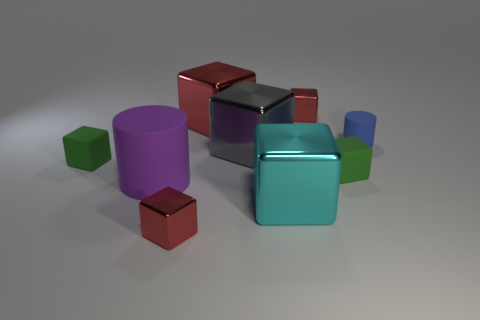Subtract all yellow spheres. How many red blocks are left? 3 Subtract 4 blocks. How many blocks are left? 3 Subtract all green cubes. How many cubes are left? 5 Subtract all large cyan metallic blocks. How many blocks are left? 6 Subtract all purple blocks. Subtract all cyan spheres. How many blocks are left? 7 Add 1 small rubber cubes. How many objects exist? 10 Subtract all blocks. How many objects are left? 2 Subtract all red objects. Subtract all large gray objects. How many objects are left? 5 Add 5 small metal blocks. How many small metal blocks are left? 7 Add 8 big matte blocks. How many big matte blocks exist? 8 